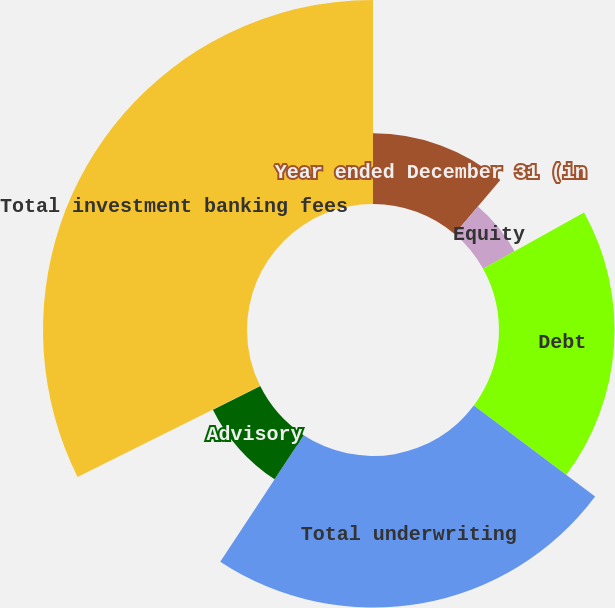Convert chart to OTSL. <chart><loc_0><loc_0><loc_500><loc_500><pie_chart><fcel>Year ended December 31 (in<fcel>Equity<fcel>Debt<fcel>Total underwriting<fcel>Advisory<fcel>Total investment banking fees<nl><fcel>11.21%<fcel>5.71%<fcel>18.32%<fcel>24.04%<fcel>8.38%<fcel>32.35%<nl></chart> 